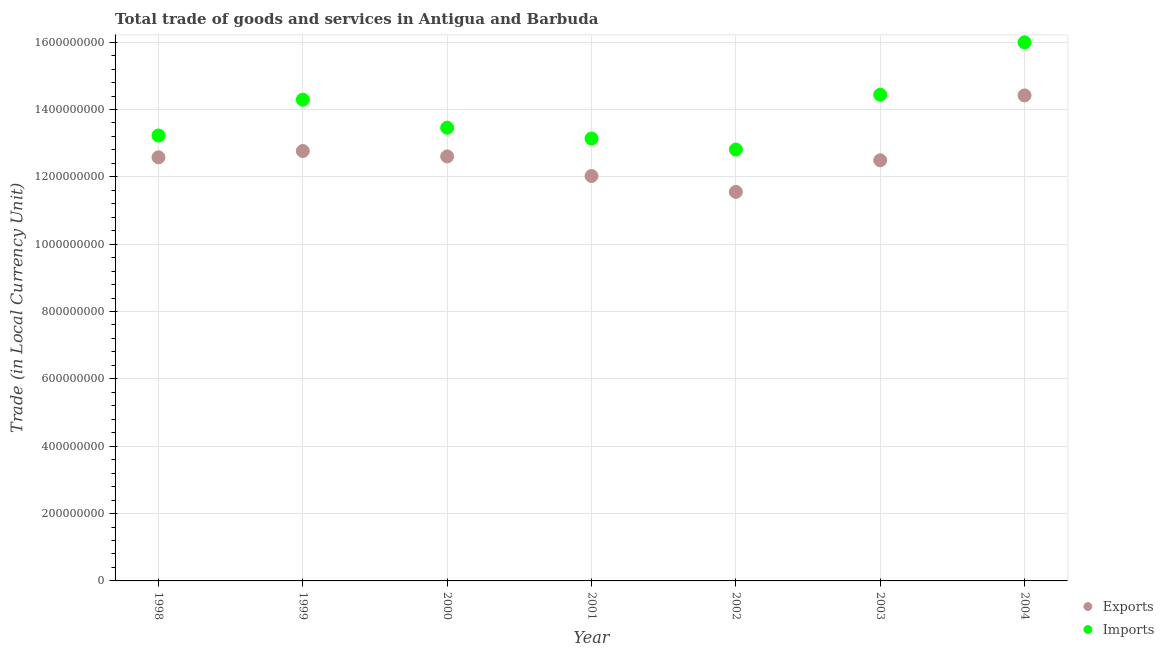What is the export of goods and services in 1999?
Keep it short and to the point. 1.28e+09. Across all years, what is the maximum export of goods and services?
Keep it short and to the point. 1.44e+09. Across all years, what is the minimum imports of goods and services?
Offer a terse response. 1.28e+09. In which year was the imports of goods and services maximum?
Give a very brief answer. 2004. What is the total imports of goods and services in the graph?
Provide a succinct answer. 9.74e+09. What is the difference between the export of goods and services in 2000 and that in 2004?
Keep it short and to the point. -1.81e+08. What is the difference between the imports of goods and services in 2003 and the export of goods and services in 2000?
Provide a short and direct response. 1.83e+08. What is the average imports of goods and services per year?
Make the answer very short. 1.39e+09. In the year 1998, what is the difference between the imports of goods and services and export of goods and services?
Your answer should be very brief. 6.49e+07. What is the ratio of the export of goods and services in 2003 to that in 2004?
Offer a terse response. 0.87. Is the imports of goods and services in 1999 less than that in 2002?
Provide a short and direct response. No. Is the difference between the export of goods and services in 1999 and 2002 greater than the difference between the imports of goods and services in 1999 and 2002?
Your answer should be very brief. No. What is the difference between the highest and the second highest imports of goods and services?
Provide a succinct answer. 1.55e+08. What is the difference between the highest and the lowest imports of goods and services?
Offer a very short reply. 3.18e+08. Does the imports of goods and services monotonically increase over the years?
Keep it short and to the point. No. Is the imports of goods and services strictly greater than the export of goods and services over the years?
Offer a terse response. Yes. Is the export of goods and services strictly less than the imports of goods and services over the years?
Your answer should be very brief. Yes. How many dotlines are there?
Offer a terse response. 2. What is the difference between two consecutive major ticks on the Y-axis?
Your answer should be compact. 2.00e+08. Does the graph contain any zero values?
Your response must be concise. No. Does the graph contain grids?
Provide a succinct answer. Yes. What is the title of the graph?
Ensure brevity in your answer.  Total trade of goods and services in Antigua and Barbuda. Does "RDB nonconcessional" appear as one of the legend labels in the graph?
Offer a terse response. No. What is the label or title of the Y-axis?
Ensure brevity in your answer.  Trade (in Local Currency Unit). What is the Trade (in Local Currency Unit) in Exports in 1998?
Ensure brevity in your answer.  1.26e+09. What is the Trade (in Local Currency Unit) in Imports in 1998?
Keep it short and to the point. 1.32e+09. What is the Trade (in Local Currency Unit) of Exports in 1999?
Your answer should be compact. 1.28e+09. What is the Trade (in Local Currency Unit) of Imports in 1999?
Keep it short and to the point. 1.43e+09. What is the Trade (in Local Currency Unit) in Exports in 2000?
Make the answer very short. 1.26e+09. What is the Trade (in Local Currency Unit) of Imports in 2000?
Your answer should be compact. 1.35e+09. What is the Trade (in Local Currency Unit) of Exports in 2001?
Your answer should be very brief. 1.20e+09. What is the Trade (in Local Currency Unit) in Imports in 2001?
Your answer should be compact. 1.31e+09. What is the Trade (in Local Currency Unit) in Exports in 2002?
Offer a terse response. 1.16e+09. What is the Trade (in Local Currency Unit) of Imports in 2002?
Offer a very short reply. 1.28e+09. What is the Trade (in Local Currency Unit) of Exports in 2003?
Keep it short and to the point. 1.25e+09. What is the Trade (in Local Currency Unit) of Imports in 2003?
Provide a succinct answer. 1.44e+09. What is the Trade (in Local Currency Unit) of Exports in 2004?
Make the answer very short. 1.44e+09. What is the Trade (in Local Currency Unit) in Imports in 2004?
Provide a short and direct response. 1.60e+09. Across all years, what is the maximum Trade (in Local Currency Unit) in Exports?
Keep it short and to the point. 1.44e+09. Across all years, what is the maximum Trade (in Local Currency Unit) in Imports?
Keep it short and to the point. 1.60e+09. Across all years, what is the minimum Trade (in Local Currency Unit) of Exports?
Provide a short and direct response. 1.16e+09. Across all years, what is the minimum Trade (in Local Currency Unit) in Imports?
Provide a succinct answer. 1.28e+09. What is the total Trade (in Local Currency Unit) of Exports in the graph?
Offer a very short reply. 8.84e+09. What is the total Trade (in Local Currency Unit) in Imports in the graph?
Your answer should be very brief. 9.74e+09. What is the difference between the Trade (in Local Currency Unit) of Exports in 1998 and that in 1999?
Your answer should be compact. -1.87e+07. What is the difference between the Trade (in Local Currency Unit) of Imports in 1998 and that in 1999?
Provide a short and direct response. -1.06e+08. What is the difference between the Trade (in Local Currency Unit) in Exports in 1998 and that in 2000?
Provide a short and direct response. -2.60e+06. What is the difference between the Trade (in Local Currency Unit) of Imports in 1998 and that in 2000?
Your answer should be very brief. -2.31e+07. What is the difference between the Trade (in Local Currency Unit) of Exports in 1998 and that in 2001?
Provide a short and direct response. 5.55e+07. What is the difference between the Trade (in Local Currency Unit) in Imports in 1998 and that in 2001?
Offer a terse response. 9.04e+06. What is the difference between the Trade (in Local Currency Unit) of Exports in 1998 and that in 2002?
Your answer should be compact. 1.03e+08. What is the difference between the Trade (in Local Currency Unit) in Imports in 1998 and that in 2002?
Make the answer very short. 4.18e+07. What is the difference between the Trade (in Local Currency Unit) of Exports in 1998 and that in 2003?
Offer a very short reply. 8.81e+06. What is the difference between the Trade (in Local Currency Unit) of Imports in 1998 and that in 2003?
Keep it short and to the point. -1.21e+08. What is the difference between the Trade (in Local Currency Unit) of Exports in 1998 and that in 2004?
Offer a very short reply. -1.84e+08. What is the difference between the Trade (in Local Currency Unit) of Imports in 1998 and that in 2004?
Offer a terse response. -2.77e+08. What is the difference between the Trade (in Local Currency Unit) of Exports in 1999 and that in 2000?
Provide a succinct answer. 1.61e+07. What is the difference between the Trade (in Local Currency Unit) of Imports in 1999 and that in 2000?
Provide a short and direct response. 8.33e+07. What is the difference between the Trade (in Local Currency Unit) of Exports in 1999 and that in 2001?
Ensure brevity in your answer.  7.42e+07. What is the difference between the Trade (in Local Currency Unit) in Imports in 1999 and that in 2001?
Offer a very short reply. 1.15e+08. What is the difference between the Trade (in Local Currency Unit) of Exports in 1999 and that in 2002?
Offer a very short reply. 1.21e+08. What is the difference between the Trade (in Local Currency Unit) of Imports in 1999 and that in 2002?
Ensure brevity in your answer.  1.48e+08. What is the difference between the Trade (in Local Currency Unit) of Exports in 1999 and that in 2003?
Provide a succinct answer. 2.75e+07. What is the difference between the Trade (in Local Currency Unit) of Imports in 1999 and that in 2003?
Provide a succinct answer. -1.47e+07. What is the difference between the Trade (in Local Currency Unit) in Exports in 1999 and that in 2004?
Offer a very short reply. -1.65e+08. What is the difference between the Trade (in Local Currency Unit) of Imports in 1999 and that in 2004?
Ensure brevity in your answer.  -1.70e+08. What is the difference between the Trade (in Local Currency Unit) in Exports in 2000 and that in 2001?
Make the answer very short. 5.81e+07. What is the difference between the Trade (in Local Currency Unit) in Imports in 2000 and that in 2001?
Your response must be concise. 3.21e+07. What is the difference between the Trade (in Local Currency Unit) of Exports in 2000 and that in 2002?
Offer a terse response. 1.05e+08. What is the difference between the Trade (in Local Currency Unit) of Imports in 2000 and that in 2002?
Your answer should be compact. 6.49e+07. What is the difference between the Trade (in Local Currency Unit) of Exports in 2000 and that in 2003?
Your response must be concise. 1.14e+07. What is the difference between the Trade (in Local Currency Unit) of Imports in 2000 and that in 2003?
Offer a terse response. -9.80e+07. What is the difference between the Trade (in Local Currency Unit) in Exports in 2000 and that in 2004?
Give a very brief answer. -1.81e+08. What is the difference between the Trade (in Local Currency Unit) of Imports in 2000 and that in 2004?
Your response must be concise. -2.53e+08. What is the difference between the Trade (in Local Currency Unit) in Exports in 2001 and that in 2002?
Provide a succinct answer. 4.72e+07. What is the difference between the Trade (in Local Currency Unit) of Imports in 2001 and that in 2002?
Offer a terse response. 3.28e+07. What is the difference between the Trade (in Local Currency Unit) in Exports in 2001 and that in 2003?
Make the answer very short. -4.67e+07. What is the difference between the Trade (in Local Currency Unit) in Imports in 2001 and that in 2003?
Provide a succinct answer. -1.30e+08. What is the difference between the Trade (in Local Currency Unit) of Exports in 2001 and that in 2004?
Your answer should be compact. -2.39e+08. What is the difference between the Trade (in Local Currency Unit) in Imports in 2001 and that in 2004?
Offer a terse response. -2.86e+08. What is the difference between the Trade (in Local Currency Unit) in Exports in 2002 and that in 2003?
Provide a succinct answer. -9.39e+07. What is the difference between the Trade (in Local Currency Unit) in Imports in 2002 and that in 2003?
Give a very brief answer. -1.63e+08. What is the difference between the Trade (in Local Currency Unit) in Exports in 2002 and that in 2004?
Ensure brevity in your answer.  -2.86e+08. What is the difference between the Trade (in Local Currency Unit) in Imports in 2002 and that in 2004?
Your answer should be very brief. -3.18e+08. What is the difference between the Trade (in Local Currency Unit) of Exports in 2003 and that in 2004?
Keep it short and to the point. -1.93e+08. What is the difference between the Trade (in Local Currency Unit) of Imports in 2003 and that in 2004?
Your answer should be compact. -1.55e+08. What is the difference between the Trade (in Local Currency Unit) of Exports in 1998 and the Trade (in Local Currency Unit) of Imports in 1999?
Your answer should be compact. -1.71e+08. What is the difference between the Trade (in Local Currency Unit) of Exports in 1998 and the Trade (in Local Currency Unit) of Imports in 2000?
Give a very brief answer. -8.79e+07. What is the difference between the Trade (in Local Currency Unit) in Exports in 1998 and the Trade (in Local Currency Unit) in Imports in 2001?
Your answer should be very brief. -5.58e+07. What is the difference between the Trade (in Local Currency Unit) in Exports in 1998 and the Trade (in Local Currency Unit) in Imports in 2002?
Make the answer very short. -2.31e+07. What is the difference between the Trade (in Local Currency Unit) of Exports in 1998 and the Trade (in Local Currency Unit) of Imports in 2003?
Make the answer very short. -1.86e+08. What is the difference between the Trade (in Local Currency Unit) in Exports in 1998 and the Trade (in Local Currency Unit) in Imports in 2004?
Offer a very short reply. -3.41e+08. What is the difference between the Trade (in Local Currency Unit) in Exports in 1999 and the Trade (in Local Currency Unit) in Imports in 2000?
Give a very brief answer. -6.92e+07. What is the difference between the Trade (in Local Currency Unit) in Exports in 1999 and the Trade (in Local Currency Unit) in Imports in 2001?
Your response must be concise. -3.71e+07. What is the difference between the Trade (in Local Currency Unit) of Exports in 1999 and the Trade (in Local Currency Unit) of Imports in 2002?
Make the answer very short. -4.35e+06. What is the difference between the Trade (in Local Currency Unit) of Exports in 1999 and the Trade (in Local Currency Unit) of Imports in 2003?
Give a very brief answer. -1.67e+08. What is the difference between the Trade (in Local Currency Unit) of Exports in 1999 and the Trade (in Local Currency Unit) of Imports in 2004?
Ensure brevity in your answer.  -3.23e+08. What is the difference between the Trade (in Local Currency Unit) in Exports in 2000 and the Trade (in Local Currency Unit) in Imports in 2001?
Make the answer very short. -5.32e+07. What is the difference between the Trade (in Local Currency Unit) in Exports in 2000 and the Trade (in Local Currency Unit) in Imports in 2002?
Give a very brief answer. -2.05e+07. What is the difference between the Trade (in Local Currency Unit) in Exports in 2000 and the Trade (in Local Currency Unit) in Imports in 2003?
Give a very brief answer. -1.83e+08. What is the difference between the Trade (in Local Currency Unit) of Exports in 2000 and the Trade (in Local Currency Unit) of Imports in 2004?
Make the answer very short. -3.39e+08. What is the difference between the Trade (in Local Currency Unit) of Exports in 2001 and the Trade (in Local Currency Unit) of Imports in 2002?
Offer a very short reply. -7.86e+07. What is the difference between the Trade (in Local Currency Unit) in Exports in 2001 and the Trade (in Local Currency Unit) in Imports in 2003?
Offer a very short reply. -2.41e+08. What is the difference between the Trade (in Local Currency Unit) of Exports in 2001 and the Trade (in Local Currency Unit) of Imports in 2004?
Your response must be concise. -3.97e+08. What is the difference between the Trade (in Local Currency Unit) in Exports in 2002 and the Trade (in Local Currency Unit) in Imports in 2003?
Give a very brief answer. -2.89e+08. What is the difference between the Trade (in Local Currency Unit) in Exports in 2002 and the Trade (in Local Currency Unit) in Imports in 2004?
Provide a succinct answer. -4.44e+08. What is the difference between the Trade (in Local Currency Unit) of Exports in 2003 and the Trade (in Local Currency Unit) of Imports in 2004?
Ensure brevity in your answer.  -3.50e+08. What is the average Trade (in Local Currency Unit) of Exports per year?
Your answer should be very brief. 1.26e+09. What is the average Trade (in Local Currency Unit) in Imports per year?
Provide a short and direct response. 1.39e+09. In the year 1998, what is the difference between the Trade (in Local Currency Unit) in Exports and Trade (in Local Currency Unit) in Imports?
Make the answer very short. -6.49e+07. In the year 1999, what is the difference between the Trade (in Local Currency Unit) of Exports and Trade (in Local Currency Unit) of Imports?
Your answer should be compact. -1.53e+08. In the year 2000, what is the difference between the Trade (in Local Currency Unit) in Exports and Trade (in Local Currency Unit) in Imports?
Make the answer very short. -8.53e+07. In the year 2001, what is the difference between the Trade (in Local Currency Unit) in Exports and Trade (in Local Currency Unit) in Imports?
Offer a terse response. -1.11e+08. In the year 2002, what is the difference between the Trade (in Local Currency Unit) of Exports and Trade (in Local Currency Unit) of Imports?
Provide a short and direct response. -1.26e+08. In the year 2003, what is the difference between the Trade (in Local Currency Unit) of Exports and Trade (in Local Currency Unit) of Imports?
Your response must be concise. -1.95e+08. In the year 2004, what is the difference between the Trade (in Local Currency Unit) of Exports and Trade (in Local Currency Unit) of Imports?
Offer a very short reply. -1.58e+08. What is the ratio of the Trade (in Local Currency Unit) of Exports in 1998 to that in 1999?
Give a very brief answer. 0.99. What is the ratio of the Trade (in Local Currency Unit) of Imports in 1998 to that in 1999?
Offer a very short reply. 0.93. What is the ratio of the Trade (in Local Currency Unit) in Exports in 1998 to that in 2000?
Make the answer very short. 1. What is the ratio of the Trade (in Local Currency Unit) in Imports in 1998 to that in 2000?
Give a very brief answer. 0.98. What is the ratio of the Trade (in Local Currency Unit) of Exports in 1998 to that in 2001?
Provide a short and direct response. 1.05. What is the ratio of the Trade (in Local Currency Unit) in Imports in 1998 to that in 2001?
Your response must be concise. 1.01. What is the ratio of the Trade (in Local Currency Unit) in Exports in 1998 to that in 2002?
Ensure brevity in your answer.  1.09. What is the ratio of the Trade (in Local Currency Unit) of Imports in 1998 to that in 2002?
Keep it short and to the point. 1.03. What is the ratio of the Trade (in Local Currency Unit) of Exports in 1998 to that in 2003?
Provide a succinct answer. 1.01. What is the ratio of the Trade (in Local Currency Unit) in Imports in 1998 to that in 2003?
Make the answer very short. 0.92. What is the ratio of the Trade (in Local Currency Unit) in Exports in 1998 to that in 2004?
Your response must be concise. 0.87. What is the ratio of the Trade (in Local Currency Unit) of Imports in 1998 to that in 2004?
Give a very brief answer. 0.83. What is the ratio of the Trade (in Local Currency Unit) of Exports in 1999 to that in 2000?
Give a very brief answer. 1.01. What is the ratio of the Trade (in Local Currency Unit) in Imports in 1999 to that in 2000?
Your response must be concise. 1.06. What is the ratio of the Trade (in Local Currency Unit) of Exports in 1999 to that in 2001?
Make the answer very short. 1.06. What is the ratio of the Trade (in Local Currency Unit) of Imports in 1999 to that in 2001?
Offer a terse response. 1.09. What is the ratio of the Trade (in Local Currency Unit) in Exports in 1999 to that in 2002?
Your answer should be very brief. 1.11. What is the ratio of the Trade (in Local Currency Unit) in Imports in 1999 to that in 2002?
Provide a short and direct response. 1.12. What is the ratio of the Trade (in Local Currency Unit) in Imports in 1999 to that in 2003?
Provide a succinct answer. 0.99. What is the ratio of the Trade (in Local Currency Unit) in Exports in 1999 to that in 2004?
Your answer should be compact. 0.89. What is the ratio of the Trade (in Local Currency Unit) in Imports in 1999 to that in 2004?
Your answer should be compact. 0.89. What is the ratio of the Trade (in Local Currency Unit) in Exports in 2000 to that in 2001?
Make the answer very short. 1.05. What is the ratio of the Trade (in Local Currency Unit) in Imports in 2000 to that in 2001?
Offer a very short reply. 1.02. What is the ratio of the Trade (in Local Currency Unit) in Exports in 2000 to that in 2002?
Your answer should be compact. 1.09. What is the ratio of the Trade (in Local Currency Unit) in Imports in 2000 to that in 2002?
Your answer should be compact. 1.05. What is the ratio of the Trade (in Local Currency Unit) of Exports in 2000 to that in 2003?
Give a very brief answer. 1.01. What is the ratio of the Trade (in Local Currency Unit) in Imports in 2000 to that in 2003?
Keep it short and to the point. 0.93. What is the ratio of the Trade (in Local Currency Unit) of Exports in 2000 to that in 2004?
Provide a succinct answer. 0.87. What is the ratio of the Trade (in Local Currency Unit) of Imports in 2000 to that in 2004?
Make the answer very short. 0.84. What is the ratio of the Trade (in Local Currency Unit) of Exports in 2001 to that in 2002?
Your answer should be compact. 1.04. What is the ratio of the Trade (in Local Currency Unit) of Imports in 2001 to that in 2002?
Offer a very short reply. 1.03. What is the ratio of the Trade (in Local Currency Unit) in Exports in 2001 to that in 2003?
Your response must be concise. 0.96. What is the ratio of the Trade (in Local Currency Unit) in Imports in 2001 to that in 2003?
Your answer should be compact. 0.91. What is the ratio of the Trade (in Local Currency Unit) in Exports in 2001 to that in 2004?
Your response must be concise. 0.83. What is the ratio of the Trade (in Local Currency Unit) in Imports in 2001 to that in 2004?
Offer a very short reply. 0.82. What is the ratio of the Trade (in Local Currency Unit) in Exports in 2002 to that in 2003?
Your response must be concise. 0.92. What is the ratio of the Trade (in Local Currency Unit) in Imports in 2002 to that in 2003?
Your answer should be very brief. 0.89. What is the ratio of the Trade (in Local Currency Unit) of Exports in 2002 to that in 2004?
Make the answer very short. 0.8. What is the ratio of the Trade (in Local Currency Unit) of Imports in 2002 to that in 2004?
Ensure brevity in your answer.  0.8. What is the ratio of the Trade (in Local Currency Unit) of Exports in 2003 to that in 2004?
Offer a terse response. 0.87. What is the ratio of the Trade (in Local Currency Unit) of Imports in 2003 to that in 2004?
Offer a terse response. 0.9. What is the difference between the highest and the second highest Trade (in Local Currency Unit) of Exports?
Ensure brevity in your answer.  1.65e+08. What is the difference between the highest and the second highest Trade (in Local Currency Unit) in Imports?
Your answer should be very brief. 1.55e+08. What is the difference between the highest and the lowest Trade (in Local Currency Unit) in Exports?
Your answer should be compact. 2.86e+08. What is the difference between the highest and the lowest Trade (in Local Currency Unit) in Imports?
Your response must be concise. 3.18e+08. 